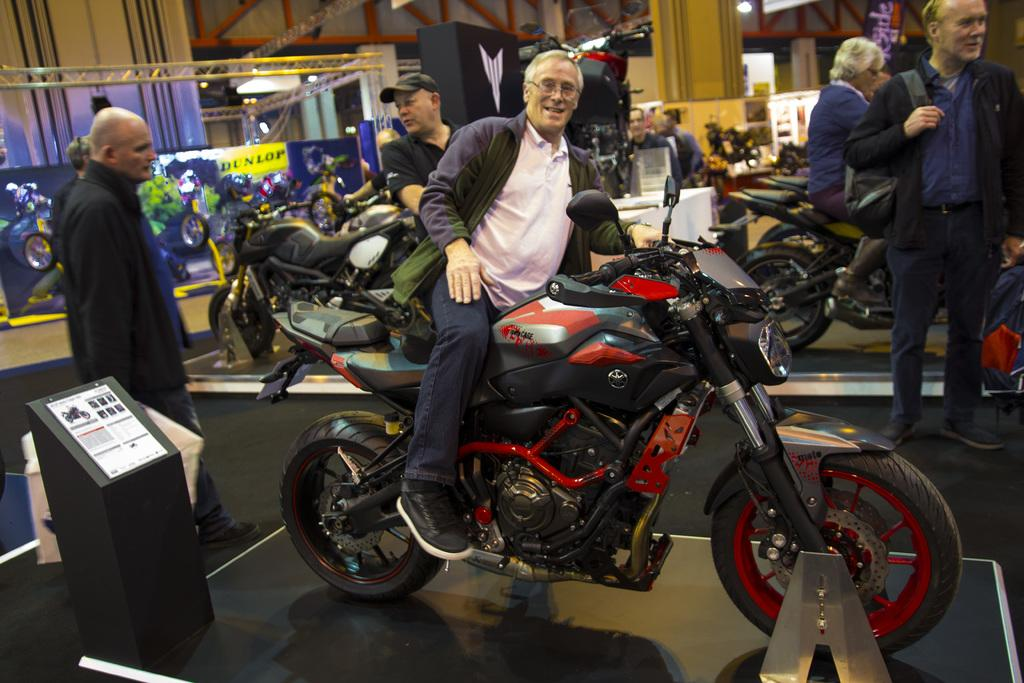Who is the main subject in the image? There is a man in the image. What is the man doing in the image? The man is on a bike. Are there any other people visible in the image? Yes, there are people standing on the side of the image. Can you tell me how many hydrants are visible in the image? There are no hydrants present in the image. Is the man swimming in the image? No, the man is not swimming in the image; he is on a bike. 